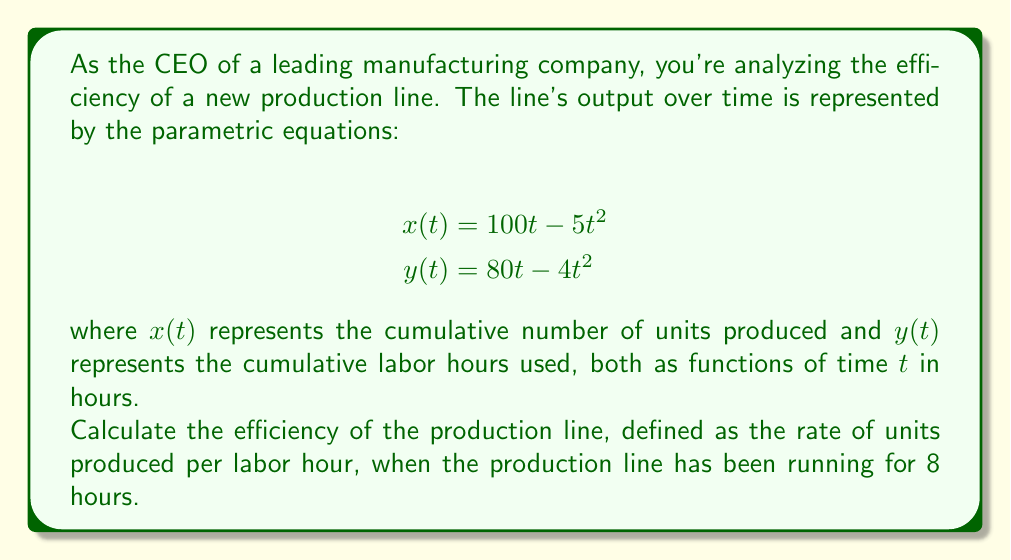Show me your answer to this math problem. To solve this problem, we'll follow these steps:

1) First, we need to find the number of units produced and labor hours used at $t = 8$ hours.

For units produced:
$$x(8) = 100(8) - 5(8^2) = 800 - 320 = 480 \text{ units}$$

For labor hours used:
$$y(8) = 80(8) - 4(8^2) = 640 - 256 = 384 \text{ hours}$$

2) Now, to find the rate of production at $t = 8$, we need to calculate the derivative of $x(t)$ with respect to $t$:

$$\frac{dx}{dt} = 100 - 10t$$

At $t = 8$:
$$\frac{dx}{dt}|_{t=8} = 100 - 10(8) = 20 \text{ units/hour}$$

3) Similarly, for the rate of labor hour usage, we calculate the derivative of $y(t)$:

$$\frac{dy}{dt} = 80 - 8t$$

At $t = 8$:
$$\frac{dy}{dt}|_{t=8} = 80 - 8(8) = 16 \text{ labor hours/hour}$$

4) The efficiency at $t = 8$ is the ratio of the rate of units produced to the rate of labor hours used:

$$\text{Efficiency} = \frac{\frac{dx}{dt}}{\frac{dy}{dt}} = \frac{20}{16} = 1.25 \text{ units/labor hour}$$

This means that at 8 hours into production, the line is producing 1.25 units per labor hour.
Answer: The efficiency of the production line after 8 hours is 1.25 units per labor hour. 